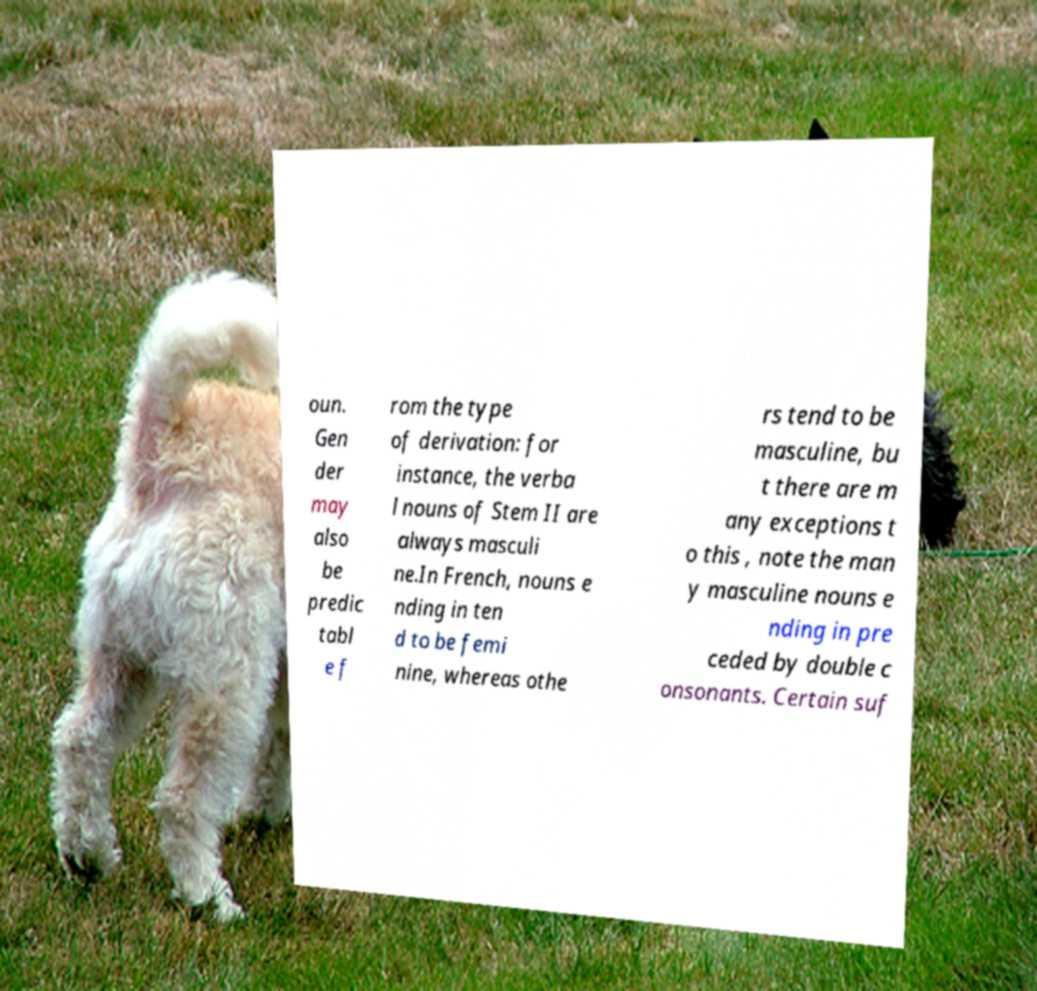Please identify and transcribe the text found in this image. oun. Gen der may also be predic tabl e f rom the type of derivation: for instance, the verba l nouns of Stem II are always masculi ne.In French, nouns e nding in ten d to be femi nine, whereas othe rs tend to be masculine, bu t there are m any exceptions t o this , note the man y masculine nouns e nding in pre ceded by double c onsonants. Certain suf 